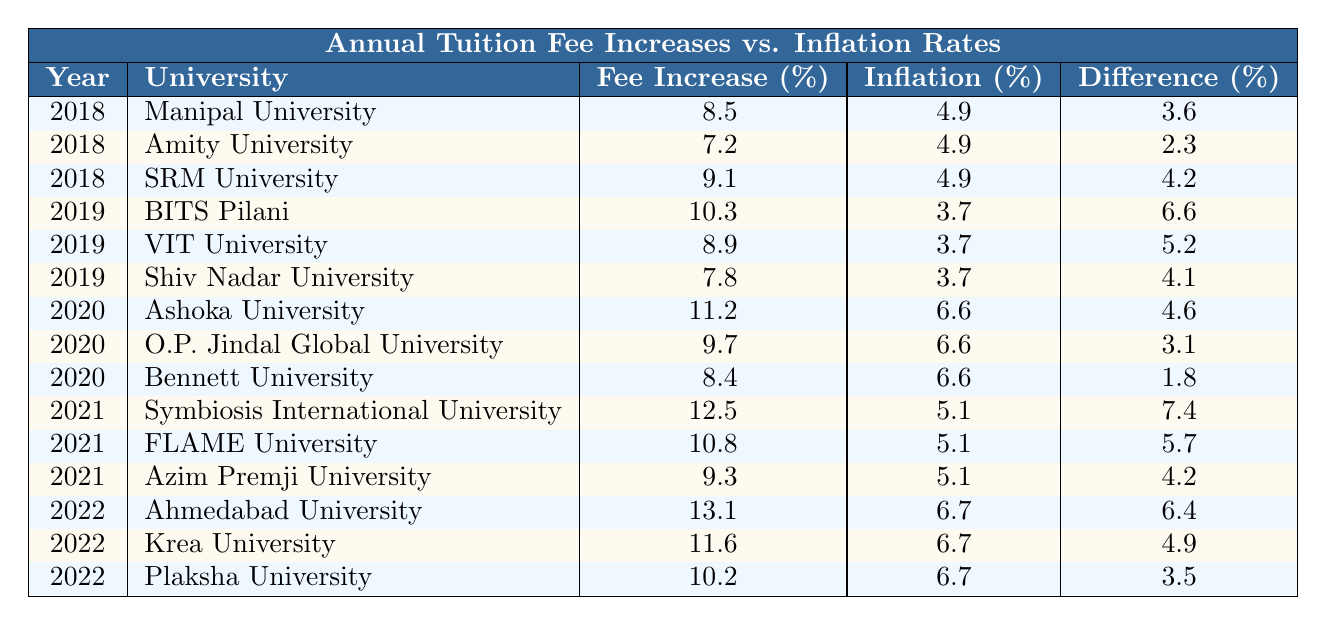What was the annual tuition fee increase percentage for BITS Pilani in 2019? The table shows the row for BITS Pilani under the year 2019, which indicates an annual tuition fee increase of 10.3%.
Answer: 10.3% Which university had the highest annual tuition fee increase in 2022? Looking at the table, the row for Ahmedabad University in 2022 shows an increase of 13.1%, which is the highest compared to other universities listed for that year.
Answer: Ahmedabad University What is the difference between the tuition fee increase and inflation rate for O.P. Jindal Global University in 2020? For O.P. Jindal Global University in 2020, the tuition fee increase is 9.7%, and the inflation rate is 6.6%. The difference is calculated as 9.7% - 6.6% = 3.1%.
Answer: 3.1% Which year saw the lowest average annual tuition fee increase across all universities listed? To find the lowest average, calculate the average for each year: 2018 = (8.5 + 7.2 + 9.1)/3 = 8.26, 2019 = (10.3 + 8.9 + 7.8)/3 = 9.33, 2020 = (11.2 + 9.7 + 8.4)/3 = 9.77, 2021 = (12.5 + 10.8 + 9.3)/3 = 10.53, and 2022 = (13.1 + 11.6 + 10.2)/3 = 11.67. The lowest average is for 2018 at 8.26%.
Answer: 2018 Did any university have an annual tuition fee increase that was less than the inflation rate in any year? By scanning the rows, it is clear that all annual tuition fee increases listed are higher than their respective inflation rates. Therefore, none of the universities had an increase lower than the inflation rate.
Answer: No What is the total percentage difference between tuition fee increases and inflation rates for all years listed? To find the total percentage difference, sum up each year's difference: (3.6 + 2.3 + 4.2 + 6.6 + 5.2 + 4.1 + 4.6 + 3.1 + 1.8 + 7.4 + 5.7 + 4.2 + 6.4 + 4.9 + 3.5) = 56.5%.
Answer: 56.5% 